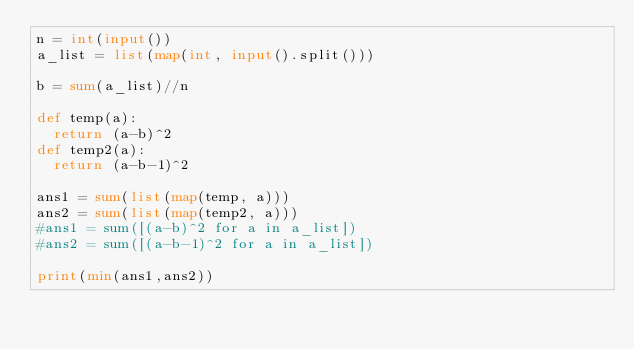Convert code to text. <code><loc_0><loc_0><loc_500><loc_500><_Python_>n = int(input())
a_list = list(map(int, input().split()))

b = sum(a_list)//n

def temp(a):
  return (a-b)^2
def temp2(a):
  return (a-b-1)^2

ans1 = sum(list(map(temp, a)))
ans2 = sum(list(map(temp2, a)))
#ans1 = sum([(a-b)^2 for a in a_list])
#ans2 = sum([(a-b-1)^2 for a in a_list])

print(min(ans1,ans2))
</code> 